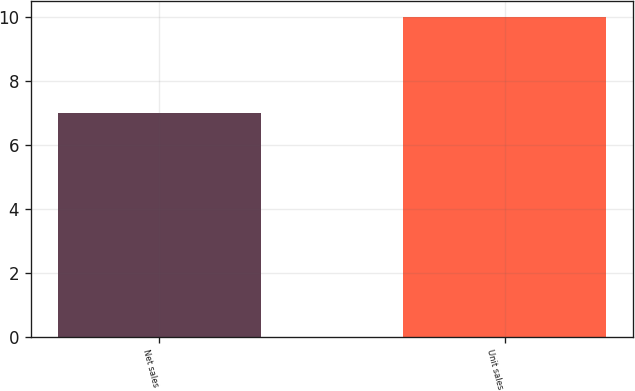Convert chart to OTSL. <chart><loc_0><loc_0><loc_500><loc_500><bar_chart><fcel>Net sales<fcel>Unit sales<nl><fcel>7<fcel>10<nl></chart> 